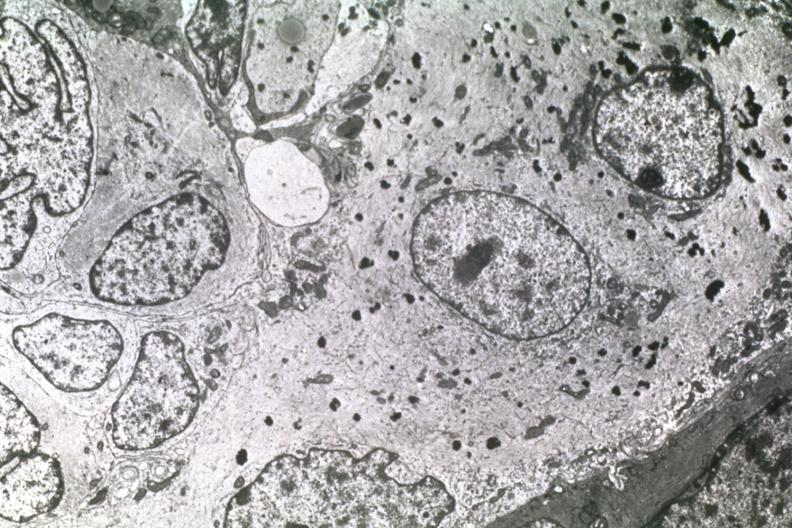s sectioned femur lesion present?
Answer the question using a single word or phrase. No 